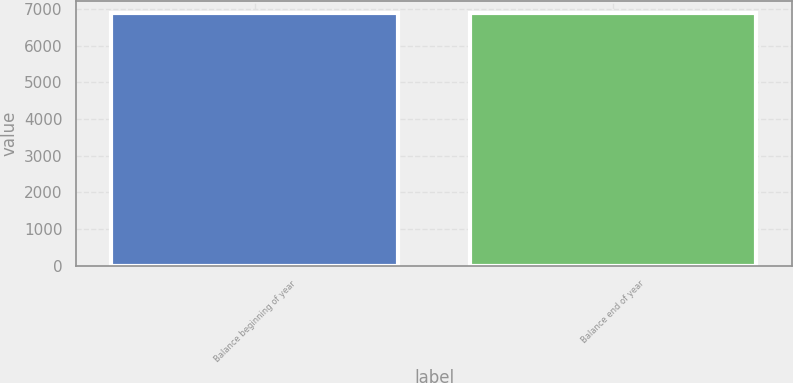Convert chart to OTSL. <chart><loc_0><loc_0><loc_500><loc_500><bar_chart><fcel>Balance beginning of year<fcel>Balance end of year<nl><fcel>6878<fcel>6878.1<nl></chart> 